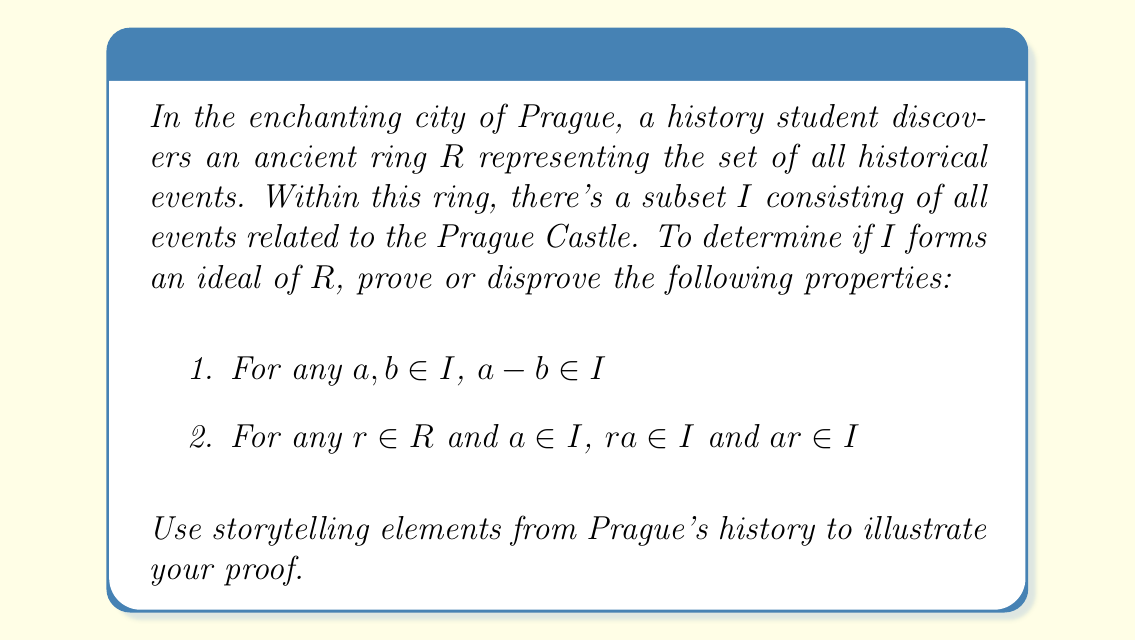Show me your answer to this math problem. Let's approach this proof using the rich history of Prague:

1. Closure under subtraction:
Let $a$ and $b$ be two events in $I$ (related to Prague Castle).
$a$: The construction of St. Vitus Cathedral in 1344
$b$: The coronation of Charles IV in 1347

$a - b$ represents the time between these events, which is still related to Prague Castle. Thus, $a - b \in I$.

2. Absorption property:
Let $r$ be any event in $R$ (Prague's history) and $a$ be an event in $I$ (related to Prague Castle).

$r$: The founding of Charles University in 1348
$a$: The construction of the Golden Lane in the 16th century

$ra$ and $ar$ represent the influence of these events on each other. For example:
$ra$: How the founding of the university influenced life at the castle
$ar$: How the construction of Golden Lane affected university scholars

Both of these resulting "events" are still related to Prague Castle, so $ra \in I$ and $ar \in I$.

To formally prove this:

Let $R$ be a ring and $I$ be a subset of $R$.

1. For any $a, b \in I$, we need to show $a - b \in I$:
   This follows from the definition of $I$ as all events related to Prague Castle. The difference between two such events is still related to the castle.

2. For any $r \in R$ and $a \in I$, we need to show $ra \in I$ and $ar \in I$:
   Since $a$ is related to Prague Castle and $r$ is any historical event, their product (representing influence or interaction) will still be related to Prague Castle.

Therefore, $I$ satisfies both properties and forms an ideal of $R$.
Answer: The subset $I$ forms an ideal of the ring $R$, as it satisfies both the closure under subtraction and the absorption property. 